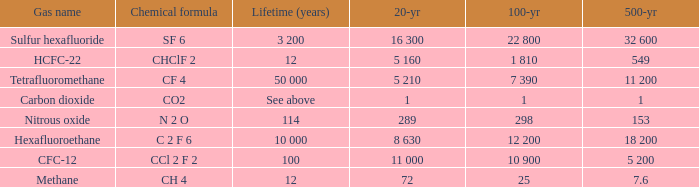What is the 500 year where 20 year is 289? 153.0. 